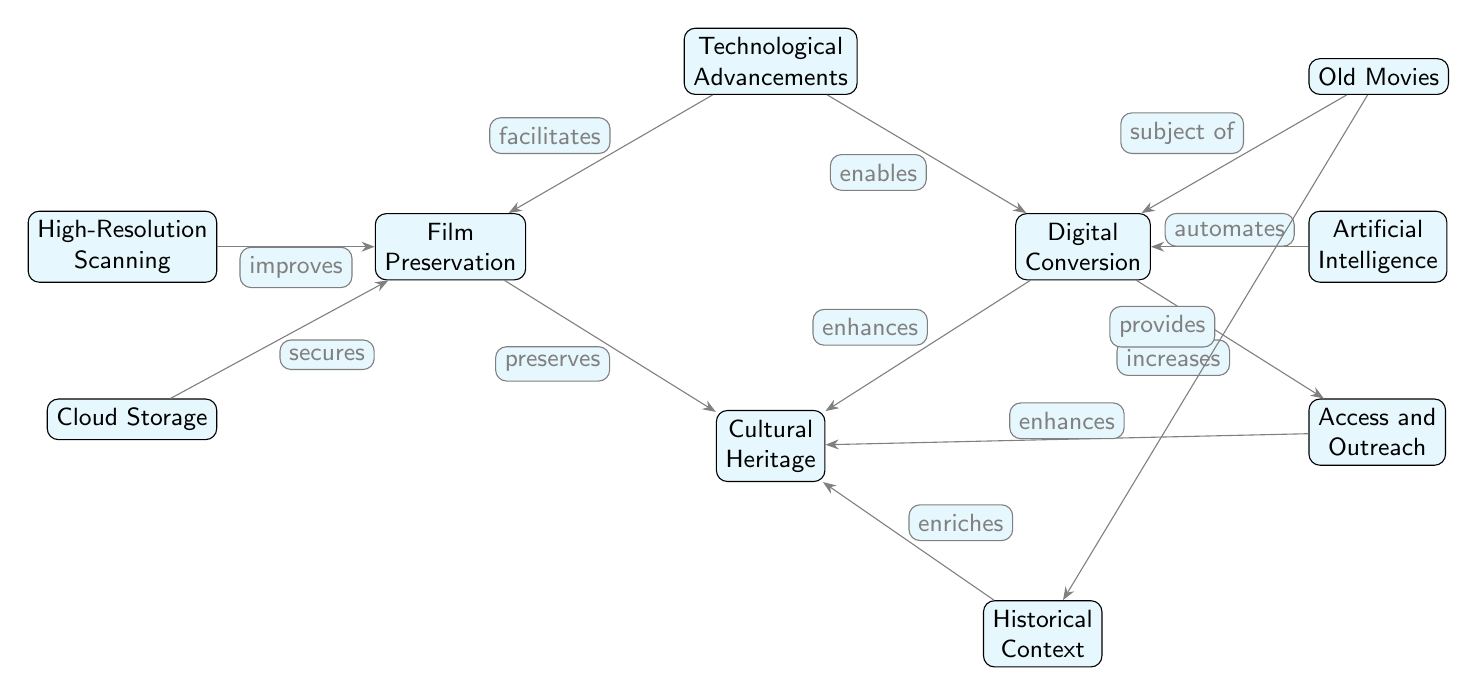What are the two main branches connected to Technological Advancements? The diagram shows two branches stemming from Technological Advancements: Film Preservation and Digital Conversion. These branches represent the areas positively affected by the advancements in technology.
Answer: Film Preservation, Digital Conversion What node is directly below Cultural Heritage? Looking at the diagram, Cultural Heritage has one node directly below it, which is Historical Context. This indicates that Historical Context is a part of the broader category of Cultural Heritage.
Answer: Historical Context How many nodes are there linked to Digital Conversion? Digital Conversion is connected to three nodes: Artificial Intelligence, Access and Outreach, and Old Movies. Counting these gives a total of three direct connections.
Answer: 3 What is the relationship between Film Preservation and Cultural Heritage? In the diagram, Film Preservation is connected to Cultural Heritage through the edge labeled "preserves," indicating that Film Preservation plays a role in maintaining Cultural Heritage.
Answer: preserves What does High-Resolution Scanning do for Film Preservation? The diagram notes that High-Resolution Scanning "improves" Film Preservation. This shows that technological advancements in scanning enhance the quality and efficacy of film preservation efforts.
Answer: improves What is the contribution of Old Movies to Cultural Heritage according to the diagram? Old Movies serve two purposes in the diagram: they are the subject of Digital Conversion and they provide a Historical Context. These contributions highlight their importance in enriching Cultural Heritage.
Answer: subject of, provides How does Artificial Intelligence influence Digital Conversion? As illustrated in the diagram, Artificial Intelligence "automates" the process of Digital Conversion. This indicates that AI technologies streamline and enhance the efficiency of converting films into digital formats.
Answer: automates What improves Film Preservation in this diagram? The diagram indicates two factors that improve Film Preservation: High-Resolution Scanning and Cloud Storage. Both elements are essential technological advancements that boost preservation efforts.
Answer: High-Resolution Scanning, Cloud Storage What enhances Cultural Heritage from Digital Conversion? Access and Outreach is the node directly linked to Digital Conversion that enhances Cultural Heritage, as denoted by the label "enhances." This suggests that through improved access, Cultural Heritage is better supported.
Answer: enhances 